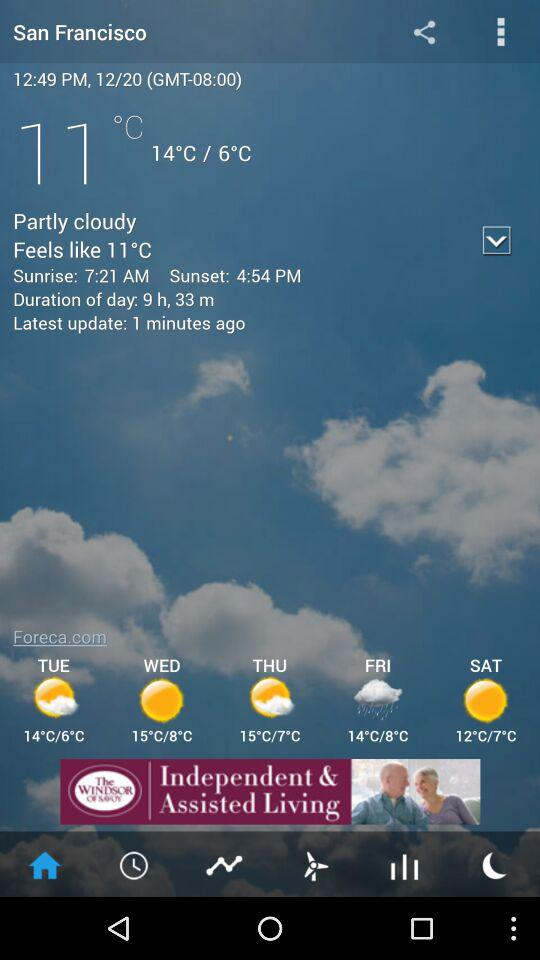What is the duration of the day? The duration of the day is 9 hours and 33 minutes. 